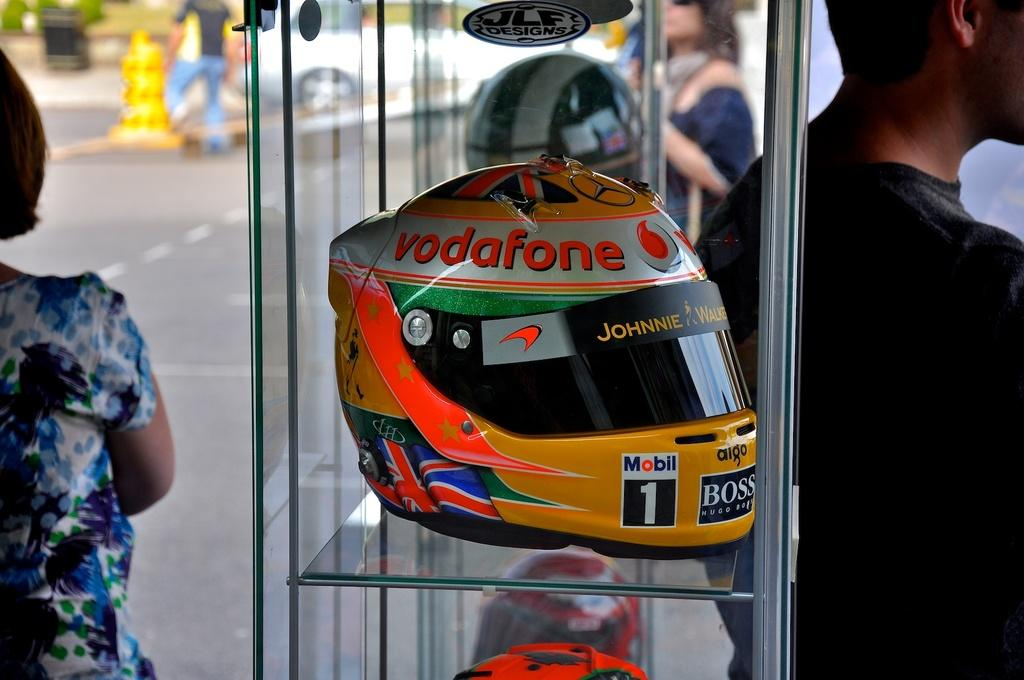What objects are on the glass shelf in the image? There are helmets on a glass shelf in the image. Can you describe the people visible in the image? The provided facts do not give any information about the people in the image, so we cannot describe them. What is the condition of the background in the image? The background of the image is blurred. What type of knowledge is being shared among the people in the image? The provided facts do not give any information about the people in the image or any knowledge being shared, so we cannot answer this question. 